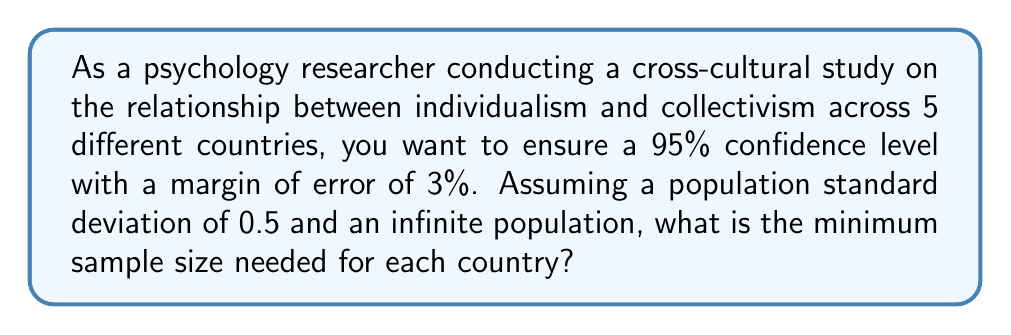Can you solve this math problem? To determine the sample size for each country in this cross-cultural research project, we'll use the formula for sample size calculation:

$$ n = \frac{Z^2 \sigma^2}{E^2} $$

Where:
$n$ = sample size
$Z$ = Z-score (1.96 for 95% confidence level)
$\sigma$ = population standard deviation
$E$ = margin of error

Given:
- Confidence level = 95% (Z = 1.96)
- Margin of error (E) = 3% = 0.03
- Population standard deviation ($\sigma$) = 0.5

Step 1: Substitute the values into the formula
$$ n = \frac{(1.96)^2 (0.5)^2}{(0.03)^2} $$

Step 2: Calculate the numerator
$$ n = \frac{(3.8416) (0.25)}{(0.03)^2} = \frac{0.9604}{0.0009} $$

Step 3: Perform the division
$$ n = 1067.11 $$

Step 4: Round up to the nearest whole number
$n = 1068$

Therefore, for each of the 5 countries in the study, a minimum sample size of 1068 participants is needed to achieve the desired confidence level and margin of error.
Answer: 1068 participants per country 